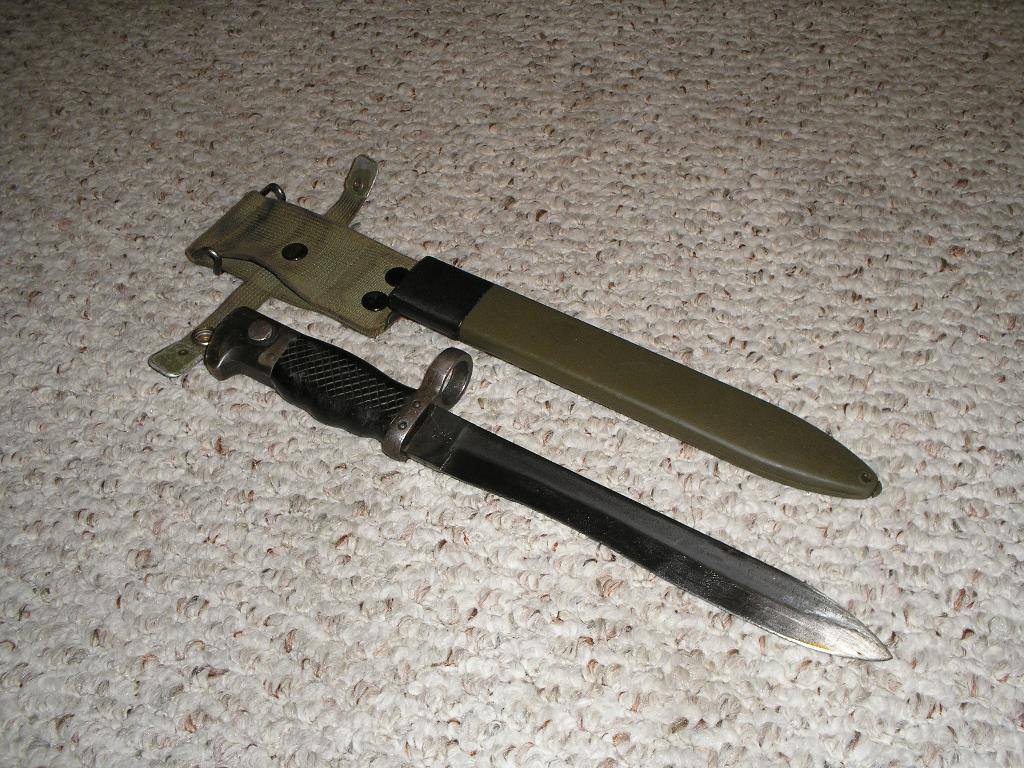What can be seen on the floor in the image? There are two objects on the floor in the image. What type of committee is meeting in the image? There is no committee meeting in the image; it only shows two objects on the floor. What is the cork used for in the image? There is no cork present in the image. 